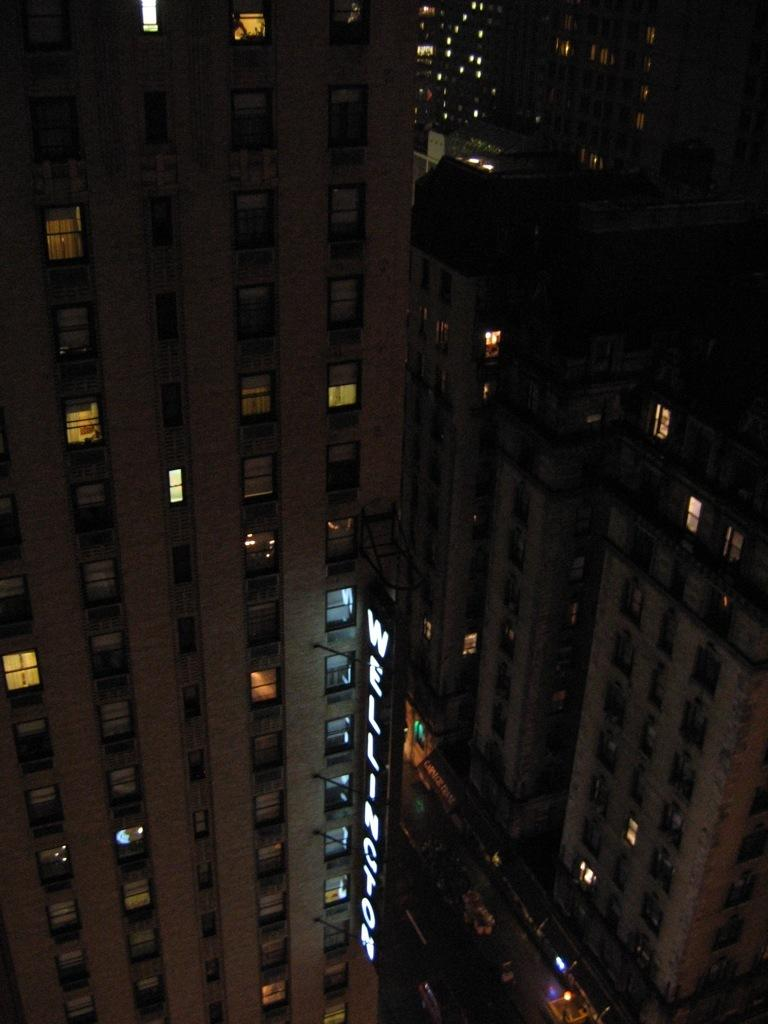What type of structures are present in the image? There are buildings in the image. What feature do the buildings have? The buildings have windows. What object can be seen in the image besides the buildings? There is a board in the image. What is written or displayed on the board? There is text on the board. What else can be seen in the image? There is a road visible in the image, and there are vehicles on the road. How does the throat of the person in the image feel? There is no person present in the image, so we cannot determine how their throat feels. 